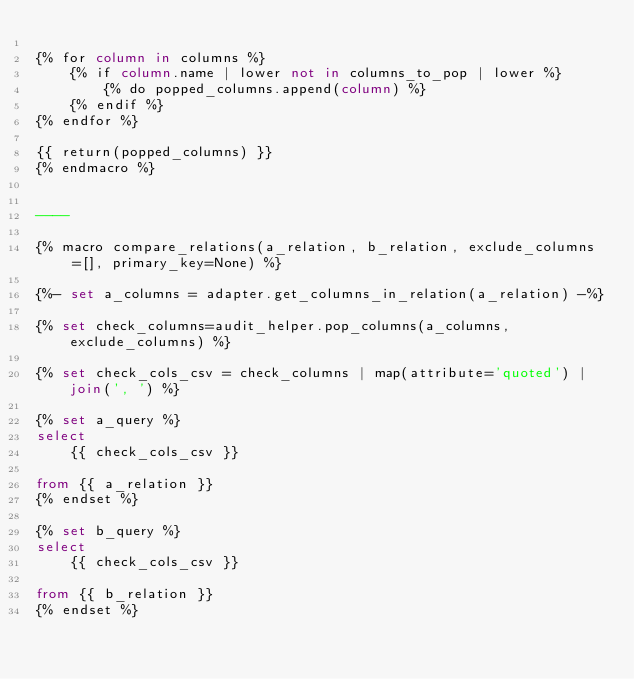<code> <loc_0><loc_0><loc_500><loc_500><_SQL_>
{% for column in columns %}
    {% if column.name | lower not in columns_to_pop | lower %}
        {% do popped_columns.append(column) %}
    {% endif %}
{% endfor %}

{{ return(popped_columns) }}
{% endmacro %}


----

{% macro compare_relations(a_relation, b_relation, exclude_columns=[], primary_key=None) %}

{%- set a_columns = adapter.get_columns_in_relation(a_relation) -%}

{% set check_columns=audit_helper.pop_columns(a_columns, exclude_columns) %}

{% set check_cols_csv = check_columns | map(attribute='quoted') | join(', ') %}

{% set a_query %}
select
    {{ check_cols_csv }}

from {{ a_relation }}
{% endset %}

{% set b_query %}
select
    {{ check_cols_csv }}

from {{ b_relation }}
{% endset %}
</code> 